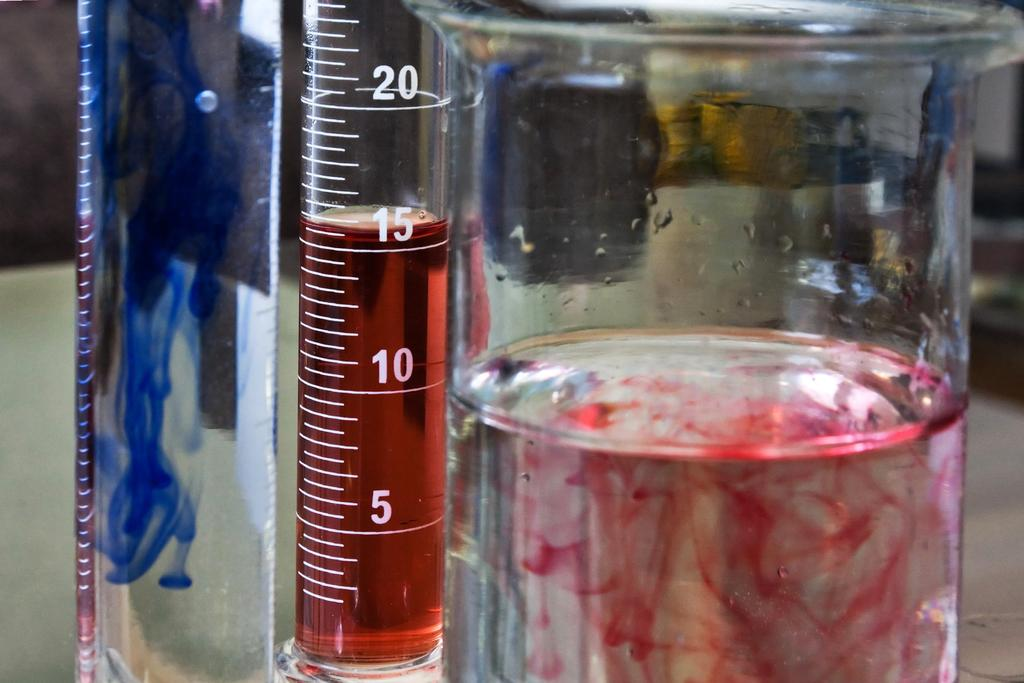What type of containers are in the image? There are glass jars in the image. What is inside the glass jars? The glass jars contain water. What colors are present in the water? The water has blue and red colors. Which team is represented by the donkey in the image? There is no donkey present in the image, so it is not possible to determine which team it might represent. 